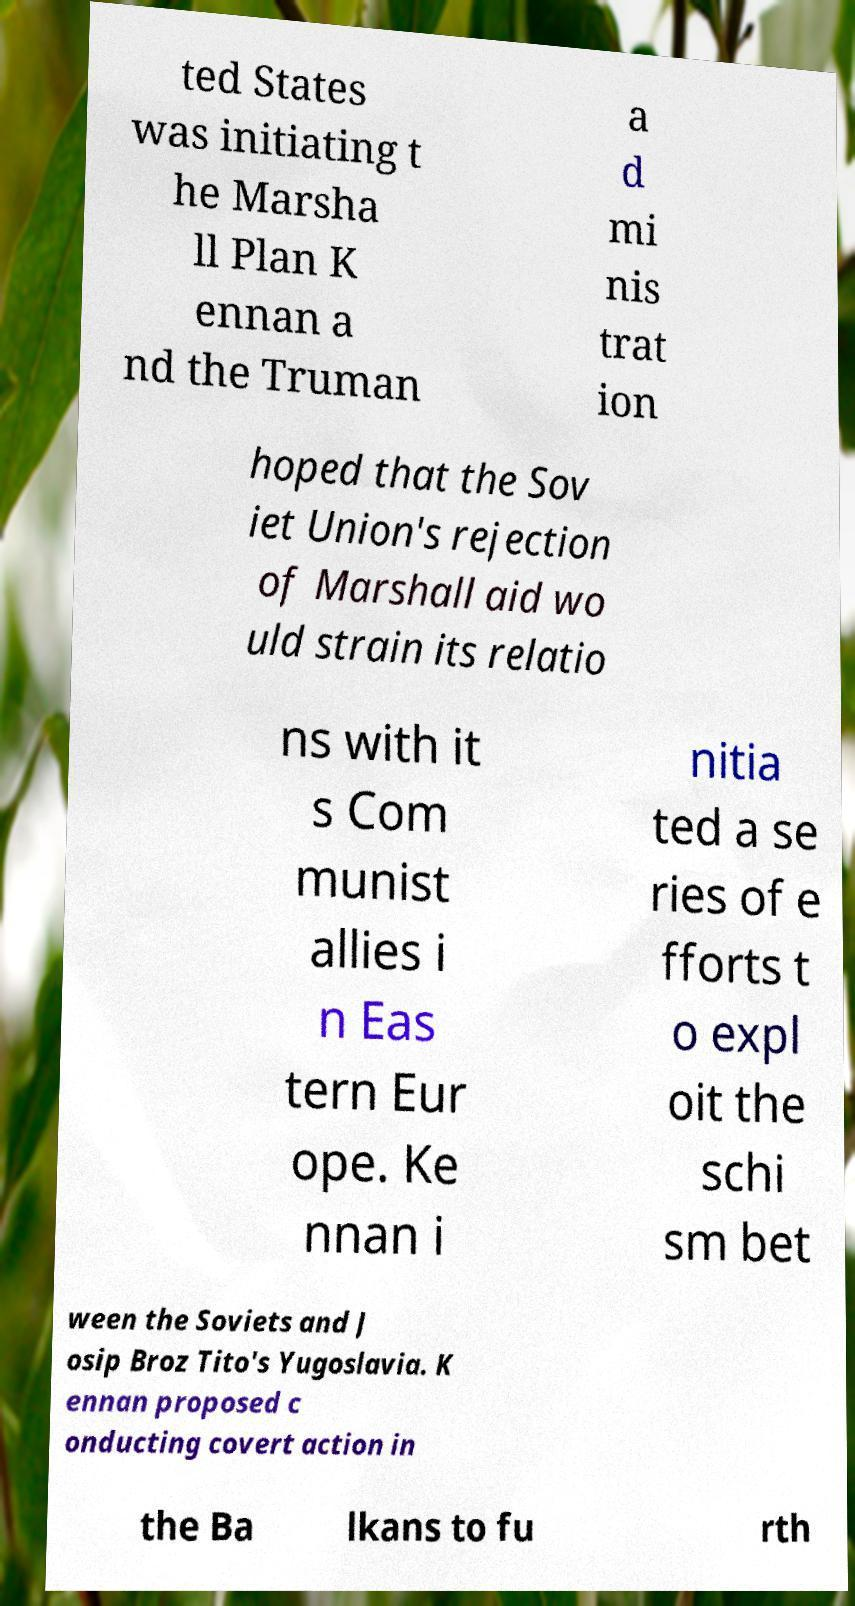Could you assist in decoding the text presented in this image and type it out clearly? ted States was initiating t he Marsha ll Plan K ennan a nd the Truman a d mi nis trat ion hoped that the Sov iet Union's rejection of Marshall aid wo uld strain its relatio ns with it s Com munist allies i n Eas tern Eur ope. Ke nnan i nitia ted a se ries of e fforts t o expl oit the schi sm bet ween the Soviets and J osip Broz Tito's Yugoslavia. K ennan proposed c onducting covert action in the Ba lkans to fu rth 